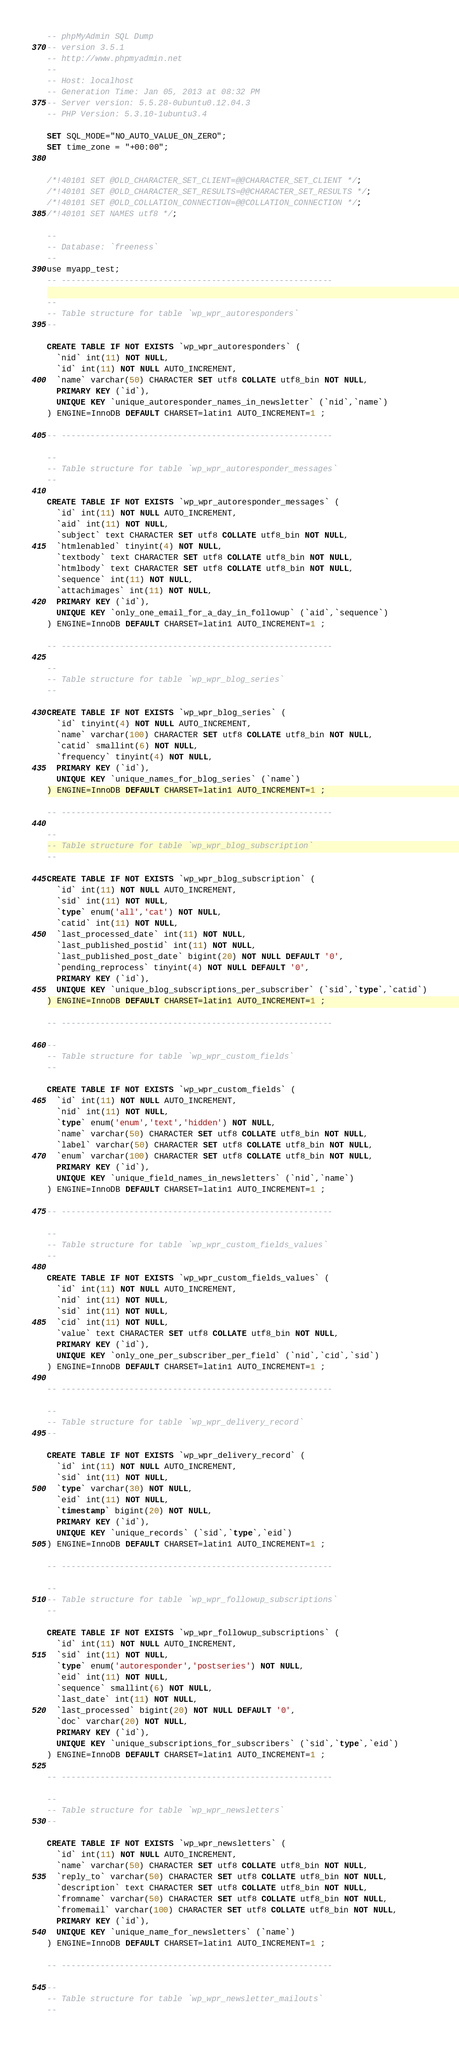Convert code to text. <code><loc_0><loc_0><loc_500><loc_500><_SQL_>-- phpMyAdmin SQL Dump
-- version 3.5.1
-- http://www.phpmyadmin.net
--
-- Host: localhost
-- Generation Time: Jan 05, 2013 at 08:32 PM
-- Server version: 5.5.28-0ubuntu0.12.04.3
-- PHP Version: 5.3.10-1ubuntu3.4

SET SQL_MODE="NO_AUTO_VALUE_ON_ZERO";
SET time_zone = "+00:00";


/*!40101 SET @OLD_CHARACTER_SET_CLIENT=@@CHARACTER_SET_CLIENT */;
/*!40101 SET @OLD_CHARACTER_SET_RESULTS=@@CHARACTER_SET_RESULTS */;
/*!40101 SET @OLD_COLLATION_CONNECTION=@@COLLATION_CONNECTION */;
/*!40101 SET NAMES utf8 */;

--
-- Database: `freeness`
--
use myapp_test;
-- --------------------------------------------------------

--
-- Table structure for table `wp_wpr_autoresponders`
--

CREATE TABLE IF NOT EXISTS `wp_wpr_autoresponders` (
  `nid` int(11) NOT NULL,
  `id` int(11) NOT NULL AUTO_INCREMENT,
  `name` varchar(50) CHARACTER SET utf8 COLLATE utf8_bin NOT NULL,
  PRIMARY KEY (`id`),
  UNIQUE KEY `unique_autoresponder_names_in_newsletter` (`nid`,`name`)
) ENGINE=InnoDB DEFAULT CHARSET=latin1 AUTO_INCREMENT=1 ;

-- --------------------------------------------------------

--
-- Table structure for table `wp_wpr_autoresponder_messages`
--

CREATE TABLE IF NOT EXISTS `wp_wpr_autoresponder_messages` (
  `id` int(11) NOT NULL AUTO_INCREMENT,
  `aid` int(11) NOT NULL,
  `subject` text CHARACTER SET utf8 COLLATE utf8_bin NOT NULL,
  `htmlenabled` tinyint(4) NOT NULL,
  `textbody` text CHARACTER SET utf8 COLLATE utf8_bin NOT NULL,
  `htmlbody` text CHARACTER SET utf8 COLLATE utf8_bin NOT NULL,
  `sequence` int(11) NOT NULL,
  `attachimages` int(11) NOT NULL,
  PRIMARY KEY (`id`),
  UNIQUE KEY `only_one_email_for_a_day_in_followup` (`aid`,`sequence`)
) ENGINE=InnoDB DEFAULT CHARSET=latin1 AUTO_INCREMENT=1 ;

-- --------------------------------------------------------

--
-- Table structure for table `wp_wpr_blog_series`
--

CREATE TABLE IF NOT EXISTS `wp_wpr_blog_series` (
  `id` tinyint(4) NOT NULL AUTO_INCREMENT,
  `name` varchar(100) CHARACTER SET utf8 COLLATE utf8_bin NOT NULL,
  `catid` smallint(6) NOT NULL,
  `frequency` tinyint(4) NOT NULL,
  PRIMARY KEY (`id`),
  UNIQUE KEY `unique_names_for_blog_series` (`name`)
) ENGINE=InnoDB DEFAULT CHARSET=latin1 AUTO_INCREMENT=1 ;

-- --------------------------------------------------------

--
-- Table structure for table `wp_wpr_blog_subscription`
--

CREATE TABLE IF NOT EXISTS `wp_wpr_blog_subscription` (
  `id` int(11) NOT NULL AUTO_INCREMENT,
  `sid` int(11) NOT NULL,
  `type` enum('all','cat') NOT NULL,
  `catid` int(11) NOT NULL,
  `last_processed_date` int(11) NOT NULL,
  `last_published_postid` int(11) NOT NULL,
  `last_published_post_date` bigint(20) NOT NULL DEFAULT '0',
  `pending_reprocess` tinyint(4) NOT NULL DEFAULT '0',
  PRIMARY KEY (`id`),
  UNIQUE KEY `unique_blog_subscriptions_per_subscriber` (`sid`,`type`,`catid`)
) ENGINE=InnoDB DEFAULT CHARSET=latin1 AUTO_INCREMENT=1 ;

-- --------------------------------------------------------

--
-- Table structure for table `wp_wpr_custom_fields`
--

CREATE TABLE IF NOT EXISTS `wp_wpr_custom_fields` (
  `id` int(11) NOT NULL AUTO_INCREMENT,
  `nid` int(11) NOT NULL,
  `type` enum('enum','text','hidden') NOT NULL,
  `name` varchar(50) CHARACTER SET utf8 COLLATE utf8_bin NOT NULL,
  `label` varchar(50) CHARACTER SET utf8 COLLATE utf8_bin NOT NULL,
  `enum` varchar(100) CHARACTER SET utf8 COLLATE utf8_bin NOT NULL,
  PRIMARY KEY (`id`),
  UNIQUE KEY `unique_field_names_in_newsletters` (`nid`,`name`)
) ENGINE=InnoDB DEFAULT CHARSET=latin1 AUTO_INCREMENT=1 ;

-- --------------------------------------------------------

--
-- Table structure for table `wp_wpr_custom_fields_values`
--

CREATE TABLE IF NOT EXISTS `wp_wpr_custom_fields_values` (
  `id` int(11) NOT NULL AUTO_INCREMENT,
  `nid` int(11) NOT NULL,
  `sid` int(11) NOT NULL,
  `cid` int(11) NOT NULL,
  `value` text CHARACTER SET utf8 COLLATE utf8_bin NOT NULL,
  PRIMARY KEY (`id`),
  UNIQUE KEY `only_one_per_subscriber_per_field` (`nid`,`cid`,`sid`)
) ENGINE=InnoDB DEFAULT CHARSET=latin1 AUTO_INCREMENT=1 ;

-- --------------------------------------------------------

--
-- Table structure for table `wp_wpr_delivery_record`
--

CREATE TABLE IF NOT EXISTS `wp_wpr_delivery_record` (
  `id` int(11) NOT NULL AUTO_INCREMENT,
  `sid` int(11) NOT NULL,
  `type` varchar(30) NOT NULL,
  `eid` int(11) NOT NULL,
  `timestamp` bigint(20) NOT NULL,
  PRIMARY KEY (`id`),
  UNIQUE KEY `unique_records` (`sid`,`type`,`eid`)
) ENGINE=InnoDB DEFAULT CHARSET=latin1 AUTO_INCREMENT=1 ;

-- --------------------------------------------------------

--
-- Table structure for table `wp_wpr_followup_subscriptions`
--

CREATE TABLE IF NOT EXISTS `wp_wpr_followup_subscriptions` (
  `id` int(11) NOT NULL AUTO_INCREMENT,
  `sid` int(11) NOT NULL,
  `type` enum('autoresponder','postseries') NOT NULL,
  `eid` int(11) NOT NULL,
  `sequence` smallint(6) NOT NULL,
  `last_date` int(11) NOT NULL,
  `last_processed` bigint(20) NOT NULL DEFAULT '0',
  `doc` varchar(20) NOT NULL,
  PRIMARY KEY (`id`),
  UNIQUE KEY `unique_subscriptions_for_subscribers` (`sid`,`type`,`eid`)
) ENGINE=InnoDB DEFAULT CHARSET=latin1 AUTO_INCREMENT=1 ;

-- --------------------------------------------------------

--
-- Table structure for table `wp_wpr_newsletters`
--

CREATE TABLE IF NOT EXISTS `wp_wpr_newsletters` (
  `id` int(11) NOT NULL AUTO_INCREMENT,
  `name` varchar(50) CHARACTER SET utf8 COLLATE utf8_bin NOT NULL,
  `reply_to` varchar(50) CHARACTER SET utf8 COLLATE utf8_bin NOT NULL,
  `description` text CHARACTER SET utf8 COLLATE utf8_bin NOT NULL,
  `fromname` varchar(50) CHARACTER SET utf8 COLLATE utf8_bin NOT NULL,
  `fromemail` varchar(100) CHARACTER SET utf8 COLLATE utf8_bin NOT NULL,
  PRIMARY KEY (`id`),
  UNIQUE KEY `unique_name_for_newsletters` (`name`)
) ENGINE=InnoDB DEFAULT CHARSET=latin1 AUTO_INCREMENT=1 ;

-- --------------------------------------------------------

--
-- Table structure for table `wp_wpr_newsletter_mailouts`
--
</code> 